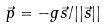<formula> <loc_0><loc_0><loc_500><loc_500>\vec { p } = - g \vec { s } / | | \vec { s } | |</formula> 